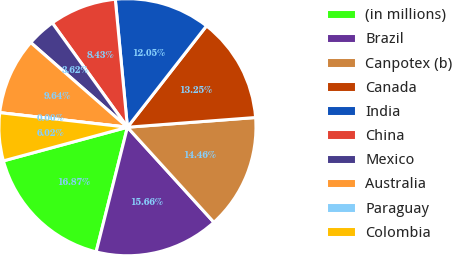Convert chart. <chart><loc_0><loc_0><loc_500><loc_500><pie_chart><fcel>(in millions)<fcel>Brazil<fcel>Canpotex (b)<fcel>Canada<fcel>India<fcel>China<fcel>Mexico<fcel>Australia<fcel>Paraguay<fcel>Colombia<nl><fcel>16.87%<fcel>15.66%<fcel>14.46%<fcel>13.25%<fcel>12.05%<fcel>8.43%<fcel>3.62%<fcel>9.64%<fcel>0.0%<fcel>6.02%<nl></chart> 